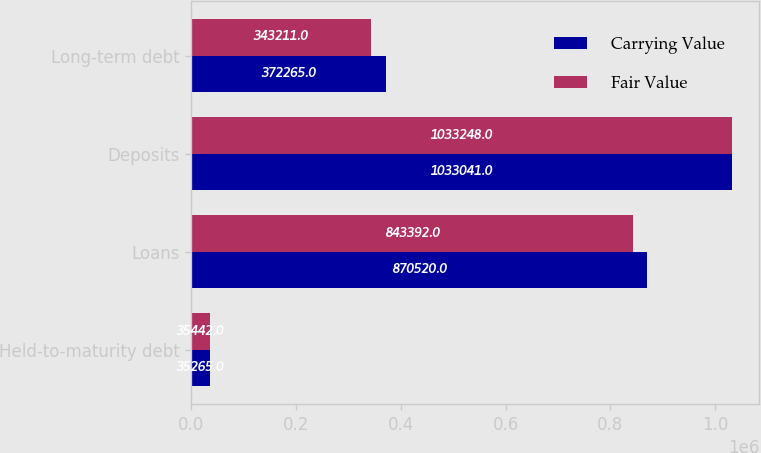Convert chart to OTSL. <chart><loc_0><loc_0><loc_500><loc_500><stacked_bar_chart><ecel><fcel>Held-to-maturity debt<fcel>Loans<fcel>Deposits<fcel>Long-term debt<nl><fcel>Carrying Value<fcel>35265<fcel>870520<fcel>1.03304e+06<fcel>372265<nl><fcel>Fair Value<fcel>35442<fcel>843392<fcel>1.03325e+06<fcel>343211<nl></chart> 